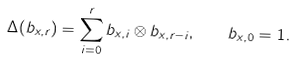<formula> <loc_0><loc_0><loc_500><loc_500>\Delta ( b _ { x , r } ) = \sum _ { i = 0 } ^ { r } b _ { x , i } \otimes b _ { x , r - i } , \quad b _ { x , 0 } = 1 .</formula> 